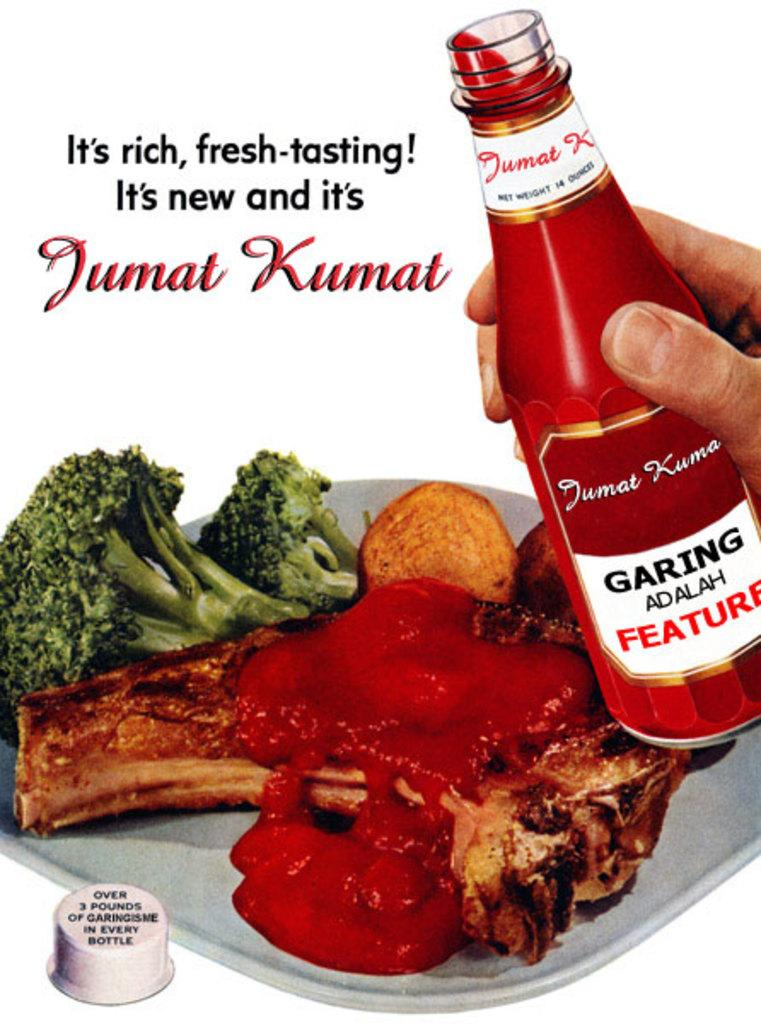Provide a one-sentence caption for the provided image. An advertisement for Jumat Kumat sauce includes a plate of food with the sauce poured over meat. 